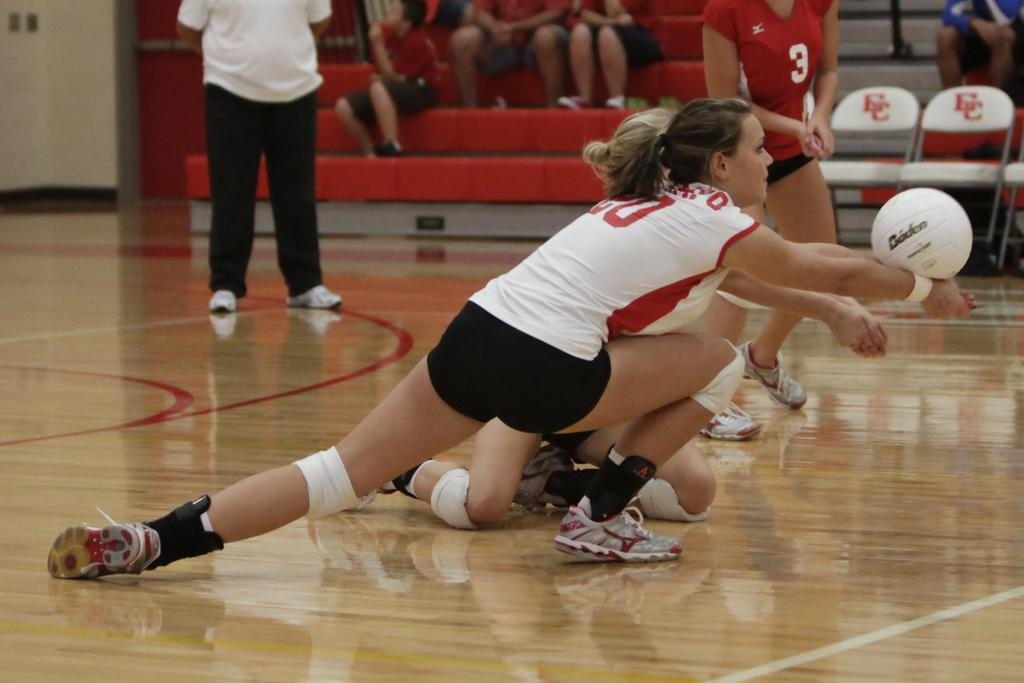What are the people in the image doing? There are people on the floor in the image, which suggests they might be playing or sitting. What object is located on the right side of the image? There is a ball on the right side of the image. What can be seen in the background of the image? There is a wall visible in the image. What type of furniture is present in the image? There are chairs visible in the image. Where are some people sitting in the image? There is a group of people sitting on a staircase visible in the image. What type of sheet is covering the earth in the image? There is no sheet or reference to the earth present in the image. What type of fowl can be seen flying in the image? There are no birds or fowl visible in the image. 